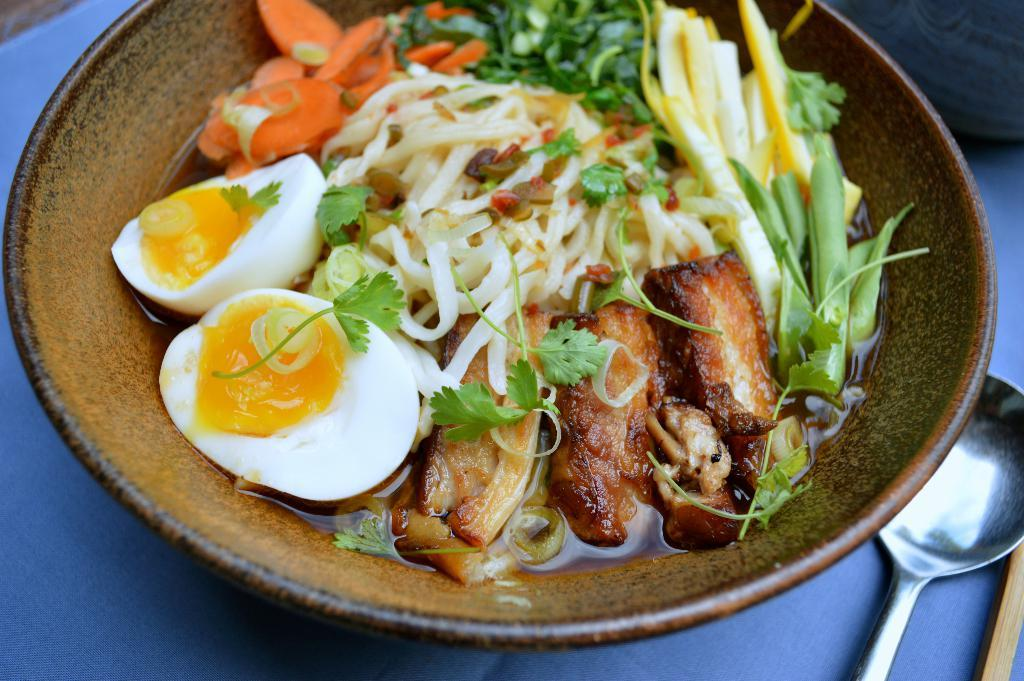What is in the bowl that is visible in the image? There is food in the bowl in the image. What utensil is visible in the image? There is a spoon visible in the image. Is the person driving a car in the image? There is no person or car present in the image, so it is not possible to determine if someone is driving in the image. 